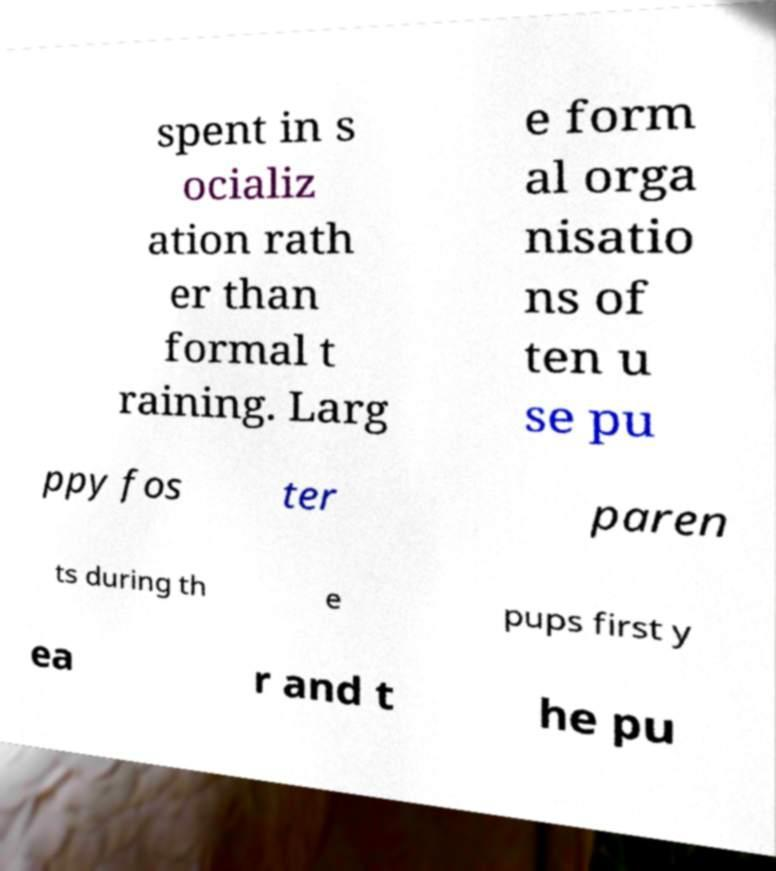Can you read and provide the text displayed in the image?This photo seems to have some interesting text. Can you extract and type it out for me? spent in s ocializ ation rath er than formal t raining. Larg e form al orga nisatio ns of ten u se pu ppy fos ter paren ts during th e pups first y ea r and t he pu 